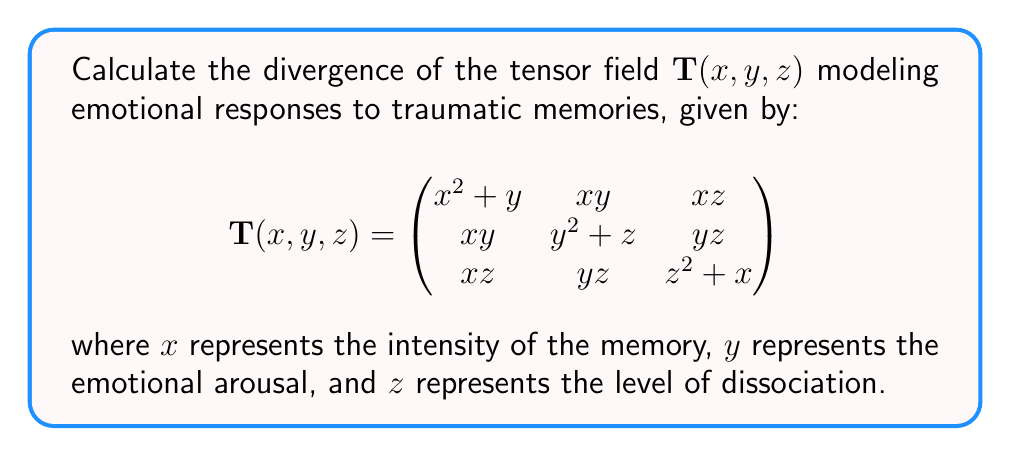Could you help me with this problem? To calculate the divergence of a tensor field, we need to sum the partial derivatives of the diagonal elements with respect to their corresponding variables:

1) First, let's identify the diagonal elements:
   $T_{11} = x^2 + y$
   $T_{22} = y^2 + z$
   $T_{33} = z^2 + x$

2) Now, we calculate the partial derivatives:
   $\frac{\partial T_{11}}{\partial x} = \frac{\partial}{\partial x}(x^2 + y) = 2x$
   $\frac{\partial T_{22}}{\partial y} = \frac{\partial}{\partial y}(y^2 + z) = 2y$
   $\frac{\partial T_{33}}{\partial z} = \frac{\partial}{\partial z}(z^2 + x) = 2z$

3) The divergence is the sum of these partial derivatives:
   $\text{div}(\mathbf{T}) = \frac{\partial T_{11}}{\partial x} + \frac{\partial T_{22}}{\partial y} + \frac{\partial T_{33}}{\partial z}$
   
4) Substituting the values:
   $\text{div}(\mathbf{T}) = 2x + 2y + 2z$

This result represents the rate at which emotional responses "flow" outward from a point in the trauma response space, considering the intensity of the memory, emotional arousal, and level of dissociation.
Answer: $2x + 2y + 2z$ 